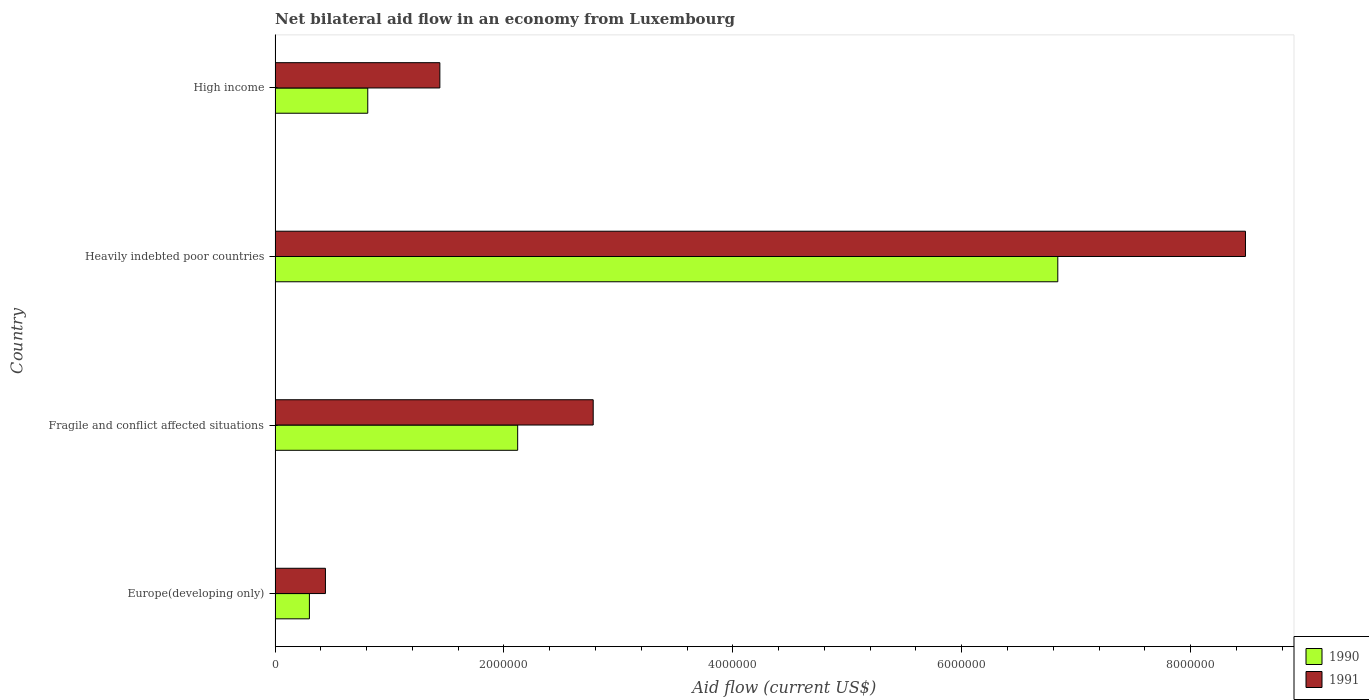Are the number of bars per tick equal to the number of legend labels?
Provide a short and direct response. Yes. Are the number of bars on each tick of the Y-axis equal?
Your answer should be compact. Yes. How many bars are there on the 1st tick from the top?
Offer a very short reply. 2. What is the label of the 3rd group of bars from the top?
Ensure brevity in your answer.  Fragile and conflict affected situations. In how many cases, is the number of bars for a given country not equal to the number of legend labels?
Provide a short and direct response. 0. What is the net bilateral aid flow in 1991 in Europe(developing only)?
Keep it short and to the point. 4.40e+05. Across all countries, what is the maximum net bilateral aid flow in 1991?
Keep it short and to the point. 8.48e+06. Across all countries, what is the minimum net bilateral aid flow in 1990?
Your answer should be compact. 3.00e+05. In which country was the net bilateral aid flow in 1991 maximum?
Your response must be concise. Heavily indebted poor countries. In which country was the net bilateral aid flow in 1991 minimum?
Ensure brevity in your answer.  Europe(developing only). What is the total net bilateral aid flow in 1991 in the graph?
Provide a succinct answer. 1.31e+07. What is the difference between the net bilateral aid flow in 1990 in Heavily indebted poor countries and that in High income?
Provide a succinct answer. 6.03e+06. What is the difference between the net bilateral aid flow in 1990 in Heavily indebted poor countries and the net bilateral aid flow in 1991 in High income?
Provide a short and direct response. 5.40e+06. What is the average net bilateral aid flow in 1990 per country?
Ensure brevity in your answer.  2.52e+06. What is the difference between the net bilateral aid flow in 1990 and net bilateral aid flow in 1991 in Fragile and conflict affected situations?
Keep it short and to the point. -6.60e+05. In how many countries, is the net bilateral aid flow in 1990 greater than 6800000 US$?
Keep it short and to the point. 1. What is the ratio of the net bilateral aid flow in 1991 in Fragile and conflict affected situations to that in High income?
Offer a terse response. 1.93. What is the difference between the highest and the second highest net bilateral aid flow in 1990?
Provide a succinct answer. 4.72e+06. What is the difference between the highest and the lowest net bilateral aid flow in 1990?
Your answer should be compact. 6.54e+06. In how many countries, is the net bilateral aid flow in 1991 greater than the average net bilateral aid flow in 1991 taken over all countries?
Give a very brief answer. 1. Is the sum of the net bilateral aid flow in 1990 in Heavily indebted poor countries and High income greater than the maximum net bilateral aid flow in 1991 across all countries?
Your response must be concise. No. What does the 2nd bar from the top in High income represents?
Keep it short and to the point. 1990. How many bars are there?
Provide a succinct answer. 8. What is the difference between two consecutive major ticks on the X-axis?
Your answer should be compact. 2.00e+06. Are the values on the major ticks of X-axis written in scientific E-notation?
Offer a very short reply. No. Does the graph contain any zero values?
Offer a very short reply. No. Does the graph contain grids?
Your answer should be compact. No. Where does the legend appear in the graph?
Your answer should be compact. Bottom right. How many legend labels are there?
Your answer should be compact. 2. What is the title of the graph?
Offer a terse response. Net bilateral aid flow in an economy from Luxembourg. Does "1987" appear as one of the legend labels in the graph?
Offer a very short reply. No. What is the Aid flow (current US$) in 1990 in Europe(developing only)?
Provide a succinct answer. 3.00e+05. What is the Aid flow (current US$) of 1990 in Fragile and conflict affected situations?
Your response must be concise. 2.12e+06. What is the Aid flow (current US$) in 1991 in Fragile and conflict affected situations?
Give a very brief answer. 2.78e+06. What is the Aid flow (current US$) in 1990 in Heavily indebted poor countries?
Give a very brief answer. 6.84e+06. What is the Aid flow (current US$) of 1991 in Heavily indebted poor countries?
Ensure brevity in your answer.  8.48e+06. What is the Aid flow (current US$) in 1990 in High income?
Keep it short and to the point. 8.10e+05. What is the Aid flow (current US$) of 1991 in High income?
Offer a very short reply. 1.44e+06. Across all countries, what is the maximum Aid flow (current US$) of 1990?
Keep it short and to the point. 6.84e+06. Across all countries, what is the maximum Aid flow (current US$) of 1991?
Offer a terse response. 8.48e+06. Across all countries, what is the minimum Aid flow (current US$) of 1991?
Give a very brief answer. 4.40e+05. What is the total Aid flow (current US$) of 1990 in the graph?
Your answer should be very brief. 1.01e+07. What is the total Aid flow (current US$) of 1991 in the graph?
Keep it short and to the point. 1.31e+07. What is the difference between the Aid flow (current US$) of 1990 in Europe(developing only) and that in Fragile and conflict affected situations?
Provide a short and direct response. -1.82e+06. What is the difference between the Aid flow (current US$) in 1991 in Europe(developing only) and that in Fragile and conflict affected situations?
Your answer should be compact. -2.34e+06. What is the difference between the Aid flow (current US$) of 1990 in Europe(developing only) and that in Heavily indebted poor countries?
Offer a very short reply. -6.54e+06. What is the difference between the Aid flow (current US$) in 1991 in Europe(developing only) and that in Heavily indebted poor countries?
Ensure brevity in your answer.  -8.04e+06. What is the difference between the Aid flow (current US$) of 1990 in Europe(developing only) and that in High income?
Your answer should be very brief. -5.10e+05. What is the difference between the Aid flow (current US$) of 1991 in Europe(developing only) and that in High income?
Your answer should be very brief. -1.00e+06. What is the difference between the Aid flow (current US$) in 1990 in Fragile and conflict affected situations and that in Heavily indebted poor countries?
Keep it short and to the point. -4.72e+06. What is the difference between the Aid flow (current US$) of 1991 in Fragile and conflict affected situations and that in Heavily indebted poor countries?
Your answer should be very brief. -5.70e+06. What is the difference between the Aid flow (current US$) of 1990 in Fragile and conflict affected situations and that in High income?
Provide a short and direct response. 1.31e+06. What is the difference between the Aid flow (current US$) of 1991 in Fragile and conflict affected situations and that in High income?
Your response must be concise. 1.34e+06. What is the difference between the Aid flow (current US$) in 1990 in Heavily indebted poor countries and that in High income?
Offer a terse response. 6.03e+06. What is the difference between the Aid flow (current US$) in 1991 in Heavily indebted poor countries and that in High income?
Keep it short and to the point. 7.04e+06. What is the difference between the Aid flow (current US$) of 1990 in Europe(developing only) and the Aid flow (current US$) of 1991 in Fragile and conflict affected situations?
Provide a succinct answer. -2.48e+06. What is the difference between the Aid flow (current US$) of 1990 in Europe(developing only) and the Aid flow (current US$) of 1991 in Heavily indebted poor countries?
Your response must be concise. -8.18e+06. What is the difference between the Aid flow (current US$) of 1990 in Europe(developing only) and the Aid flow (current US$) of 1991 in High income?
Provide a succinct answer. -1.14e+06. What is the difference between the Aid flow (current US$) of 1990 in Fragile and conflict affected situations and the Aid flow (current US$) of 1991 in Heavily indebted poor countries?
Make the answer very short. -6.36e+06. What is the difference between the Aid flow (current US$) of 1990 in Fragile and conflict affected situations and the Aid flow (current US$) of 1991 in High income?
Your answer should be compact. 6.80e+05. What is the difference between the Aid flow (current US$) in 1990 in Heavily indebted poor countries and the Aid flow (current US$) in 1991 in High income?
Offer a very short reply. 5.40e+06. What is the average Aid flow (current US$) in 1990 per country?
Your response must be concise. 2.52e+06. What is the average Aid flow (current US$) of 1991 per country?
Offer a very short reply. 3.28e+06. What is the difference between the Aid flow (current US$) of 1990 and Aid flow (current US$) of 1991 in Europe(developing only)?
Make the answer very short. -1.40e+05. What is the difference between the Aid flow (current US$) in 1990 and Aid flow (current US$) in 1991 in Fragile and conflict affected situations?
Your answer should be compact. -6.60e+05. What is the difference between the Aid flow (current US$) of 1990 and Aid flow (current US$) of 1991 in Heavily indebted poor countries?
Keep it short and to the point. -1.64e+06. What is the difference between the Aid flow (current US$) of 1990 and Aid flow (current US$) of 1991 in High income?
Your answer should be compact. -6.30e+05. What is the ratio of the Aid flow (current US$) of 1990 in Europe(developing only) to that in Fragile and conflict affected situations?
Your response must be concise. 0.14. What is the ratio of the Aid flow (current US$) of 1991 in Europe(developing only) to that in Fragile and conflict affected situations?
Make the answer very short. 0.16. What is the ratio of the Aid flow (current US$) in 1990 in Europe(developing only) to that in Heavily indebted poor countries?
Give a very brief answer. 0.04. What is the ratio of the Aid flow (current US$) of 1991 in Europe(developing only) to that in Heavily indebted poor countries?
Offer a terse response. 0.05. What is the ratio of the Aid flow (current US$) in 1990 in Europe(developing only) to that in High income?
Your answer should be very brief. 0.37. What is the ratio of the Aid flow (current US$) in 1991 in Europe(developing only) to that in High income?
Your response must be concise. 0.31. What is the ratio of the Aid flow (current US$) in 1990 in Fragile and conflict affected situations to that in Heavily indebted poor countries?
Your response must be concise. 0.31. What is the ratio of the Aid flow (current US$) in 1991 in Fragile and conflict affected situations to that in Heavily indebted poor countries?
Ensure brevity in your answer.  0.33. What is the ratio of the Aid flow (current US$) in 1990 in Fragile and conflict affected situations to that in High income?
Your response must be concise. 2.62. What is the ratio of the Aid flow (current US$) in 1991 in Fragile and conflict affected situations to that in High income?
Provide a succinct answer. 1.93. What is the ratio of the Aid flow (current US$) in 1990 in Heavily indebted poor countries to that in High income?
Give a very brief answer. 8.44. What is the ratio of the Aid flow (current US$) in 1991 in Heavily indebted poor countries to that in High income?
Your answer should be very brief. 5.89. What is the difference between the highest and the second highest Aid flow (current US$) in 1990?
Make the answer very short. 4.72e+06. What is the difference between the highest and the second highest Aid flow (current US$) of 1991?
Make the answer very short. 5.70e+06. What is the difference between the highest and the lowest Aid flow (current US$) in 1990?
Make the answer very short. 6.54e+06. What is the difference between the highest and the lowest Aid flow (current US$) in 1991?
Your answer should be very brief. 8.04e+06. 